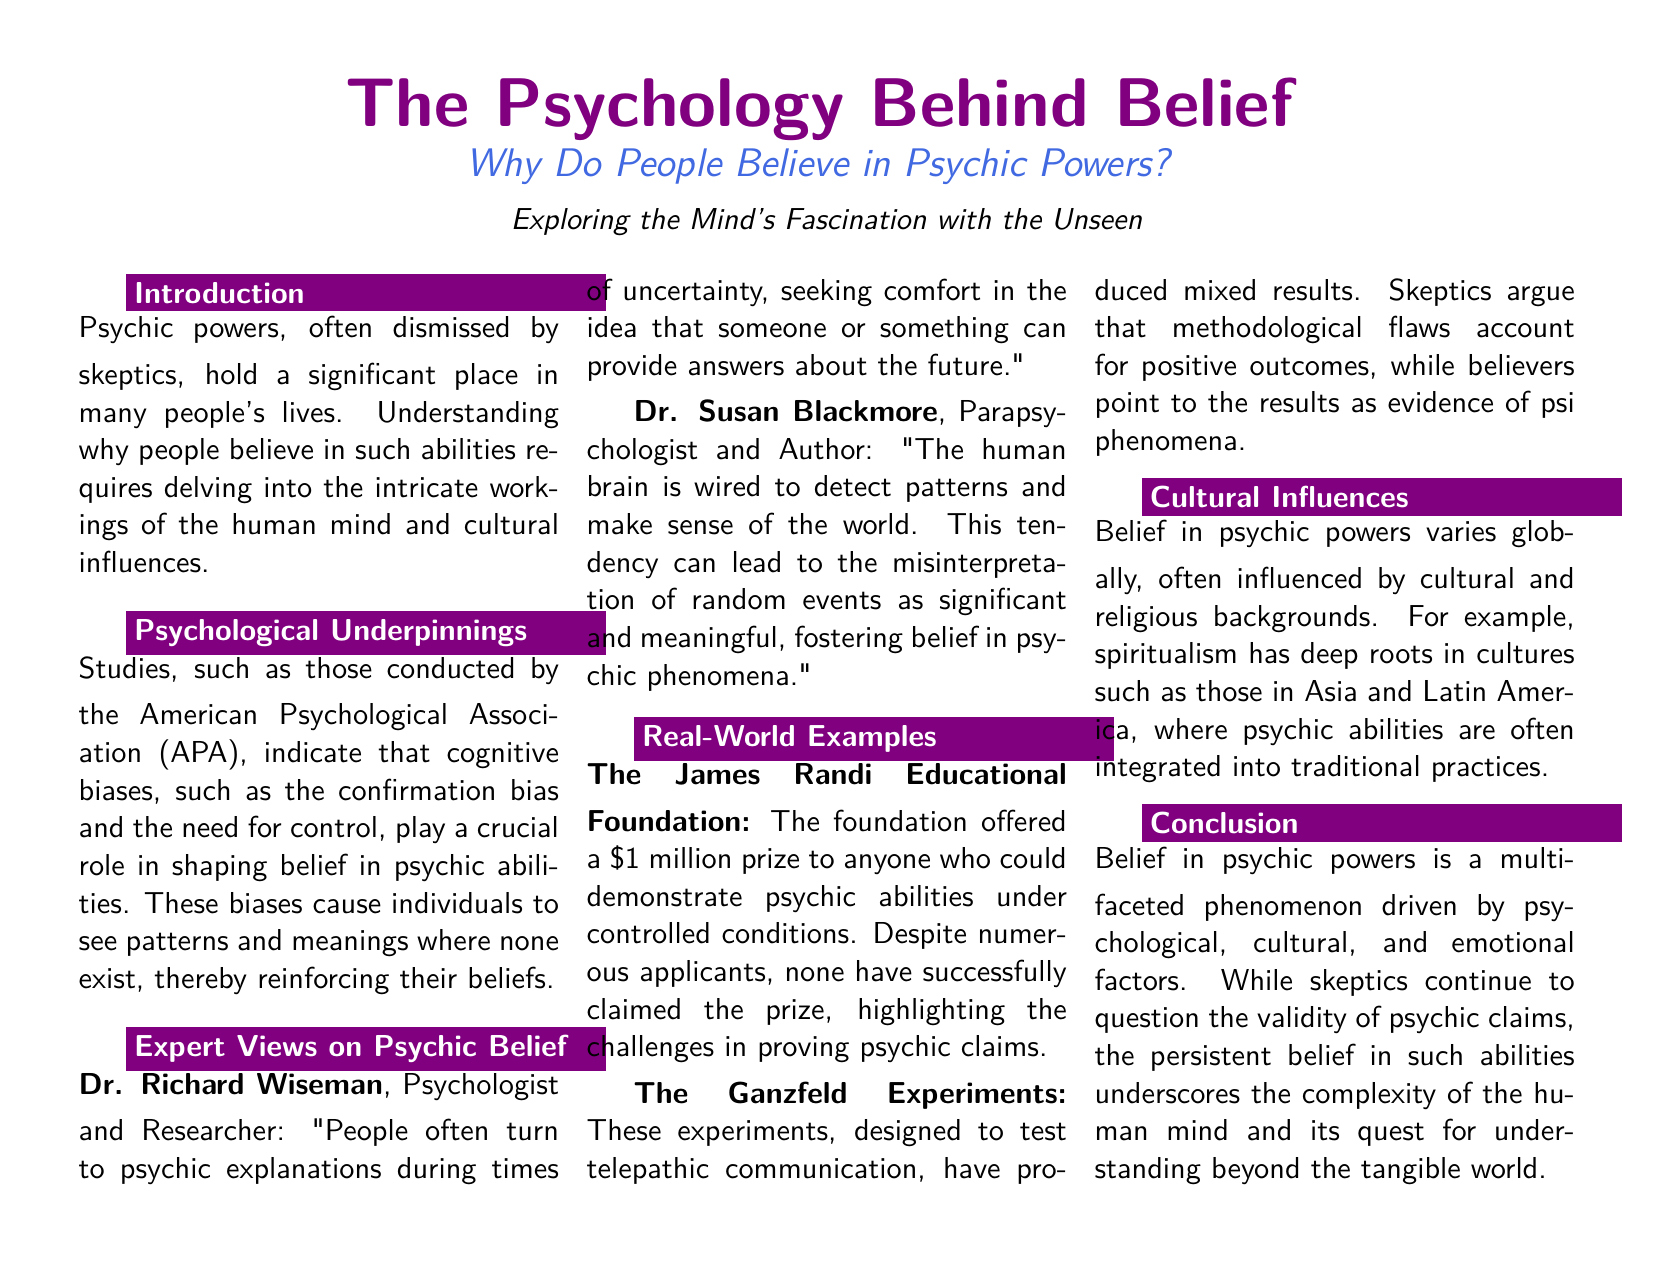What is the title of the document? The title of the document is typically highlighted, and in this case, it is "The Psychology Behind Belief".
Answer: The Psychology Behind Belief Who conducted the studies related to psychological underpinnings of belief in psychic powers? The studies related to psychological underpinnings were conducted by the American Psychological Association (APA).
Answer: American Psychological Association What does Dr. Richard Wiseman say people turn to during uncertainty? Dr. Richard Wiseman suggests that people often turn to psychic explanations during times of uncertainty.
Answer: psychic explanations Which organization offered a million-dollar prize for demonstrating psychic abilities? The organization that offered a million-dollar prize is The James Randi Educational Foundation.
Answer: The James Randi Educational Foundation What is a cultural factor that influences belief in psychic powers? Belief in psychic powers is influenced by cultural and religious backgrounds.
Answer: cultural and religious backgrounds Who is the author and parapsychologist mentioned in the document? The author and parapsychologist mentioned in the document is Dr. Susan Blackmore.
Answer: Dr. Susan Blackmore What are the Ganzfeld Experiments designed to test? The Ganzfeld Experiments are designed to test telepathic communication.
Answer: telepathic communication How are beliefs in psychic powers described in the conclusion? In the conclusion, beliefs in psychic powers are described as a multi-faceted phenomenon.
Answer: multi-faceted phenomenon In which continents are cultural roots of spiritualism mentioned? The document mentions that cultures in Asia and Latin America have deep roots in spiritualism.
Answer: Asia and Latin America 